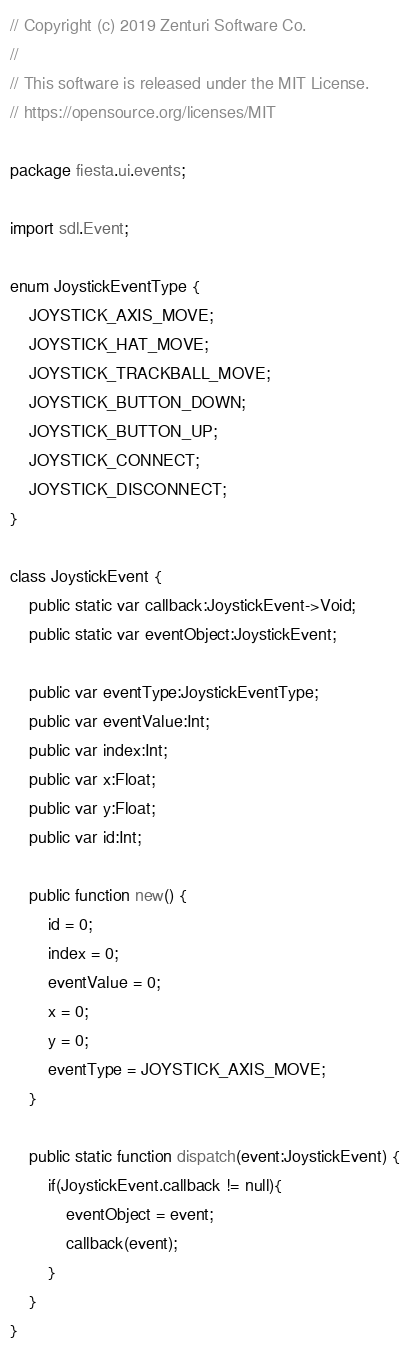Convert code to text. <code><loc_0><loc_0><loc_500><loc_500><_Haxe_>// Copyright (c) 2019 Zenturi Software Co.
// 
// This software is released under the MIT License.
// https://opensource.org/licenses/MIT

package fiesta.ui.events;

import sdl.Event;

enum JoystickEventType {
	JOYSTICK_AXIS_MOVE;
	JOYSTICK_HAT_MOVE;
	JOYSTICK_TRACKBALL_MOVE;
	JOYSTICK_BUTTON_DOWN;
	JOYSTICK_BUTTON_UP;
	JOYSTICK_CONNECT;
	JOYSTICK_DISCONNECT;
}

class JoystickEvent {
	public static var callback:JoystickEvent->Void;
	public static var eventObject:JoystickEvent;

	public var eventType:JoystickEventType;
	public var eventValue:Int;
	public var index:Int;
	public var x:Float;
	public var y:Float;
	public var id:Int;

	public function new() {
		id = 0;
		index = 0;
		eventValue = 0;
		x = 0;
		y = 0;
		eventType = JOYSTICK_AXIS_MOVE;
	}

	public static function dispatch(event:JoystickEvent) {
        if(JoystickEvent.callback != null){
			eventObject = event;
            callback(event);
        }
    }
}
</code> 